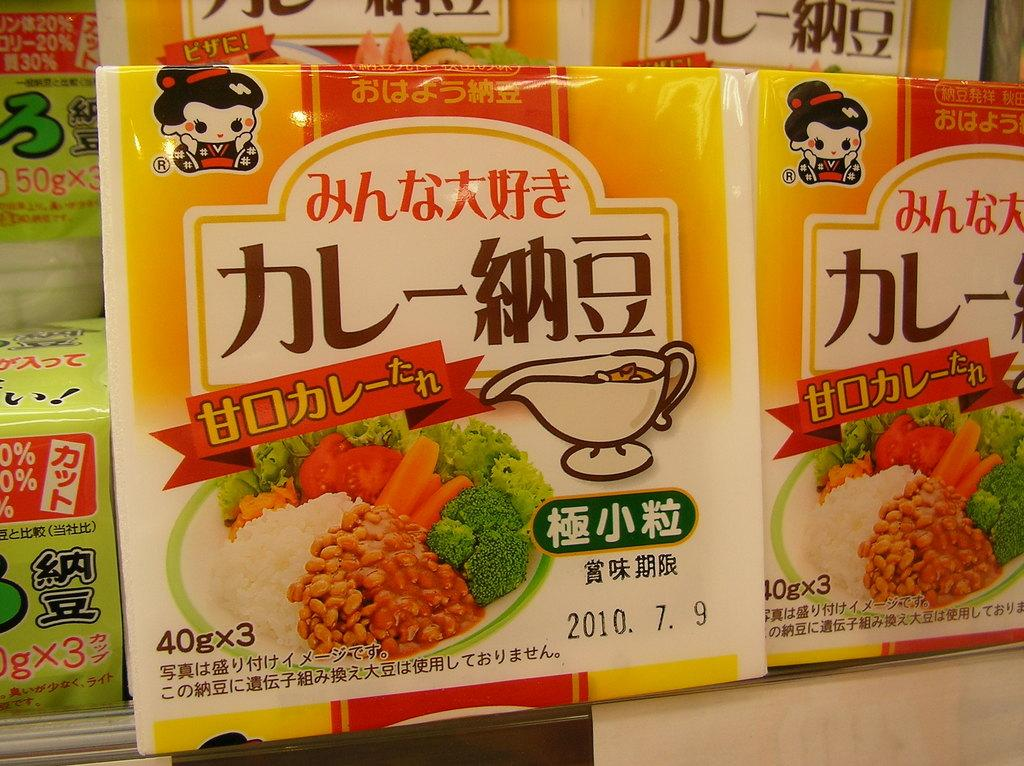What objects are present in the image that have text on them? There are packets in the image, and they have text on them. What other information can be found on the packets? The packets have dates, weights, and images on them. How many feet are visible in the image? There are no feet visible in the image; it features packets with text, dates, weights, and images on them. How many heads can be seen in the image? There are no heads visible in the image; it features packets with text, dates, weights, and images on them. 